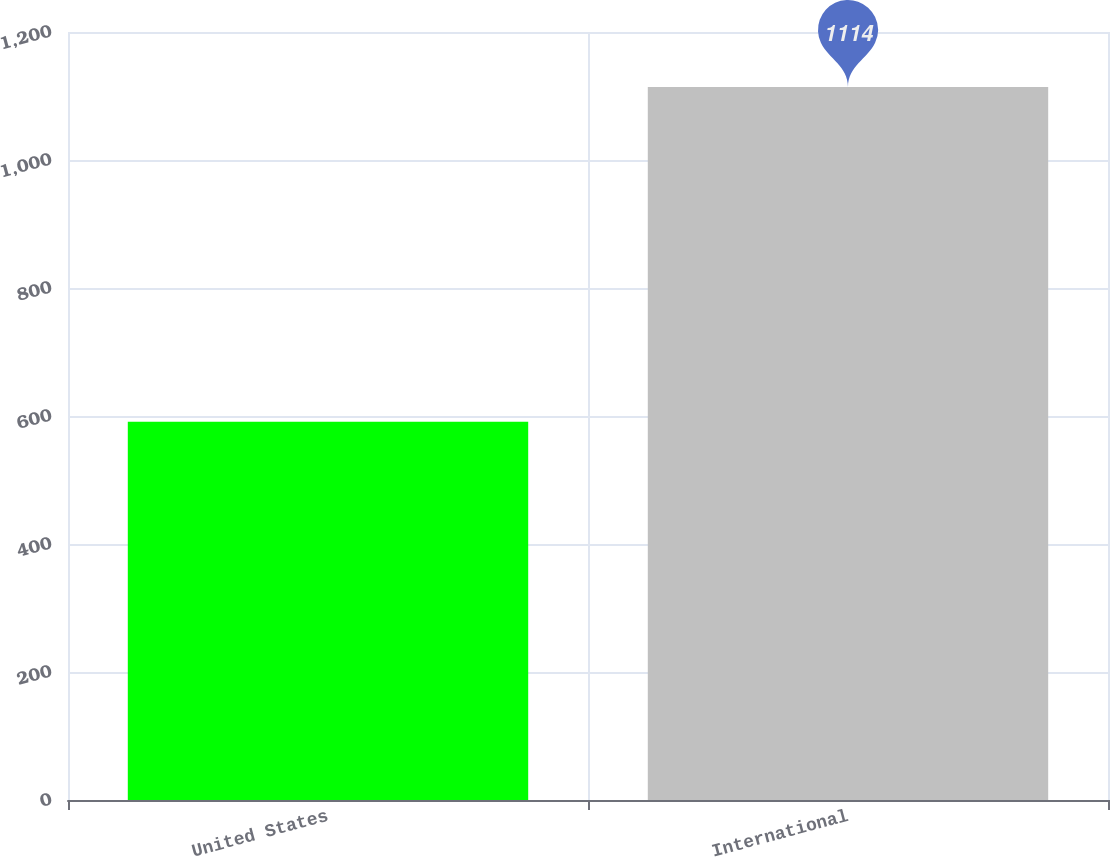<chart> <loc_0><loc_0><loc_500><loc_500><bar_chart><fcel>United States<fcel>International<nl><fcel>591<fcel>1114<nl></chart> 